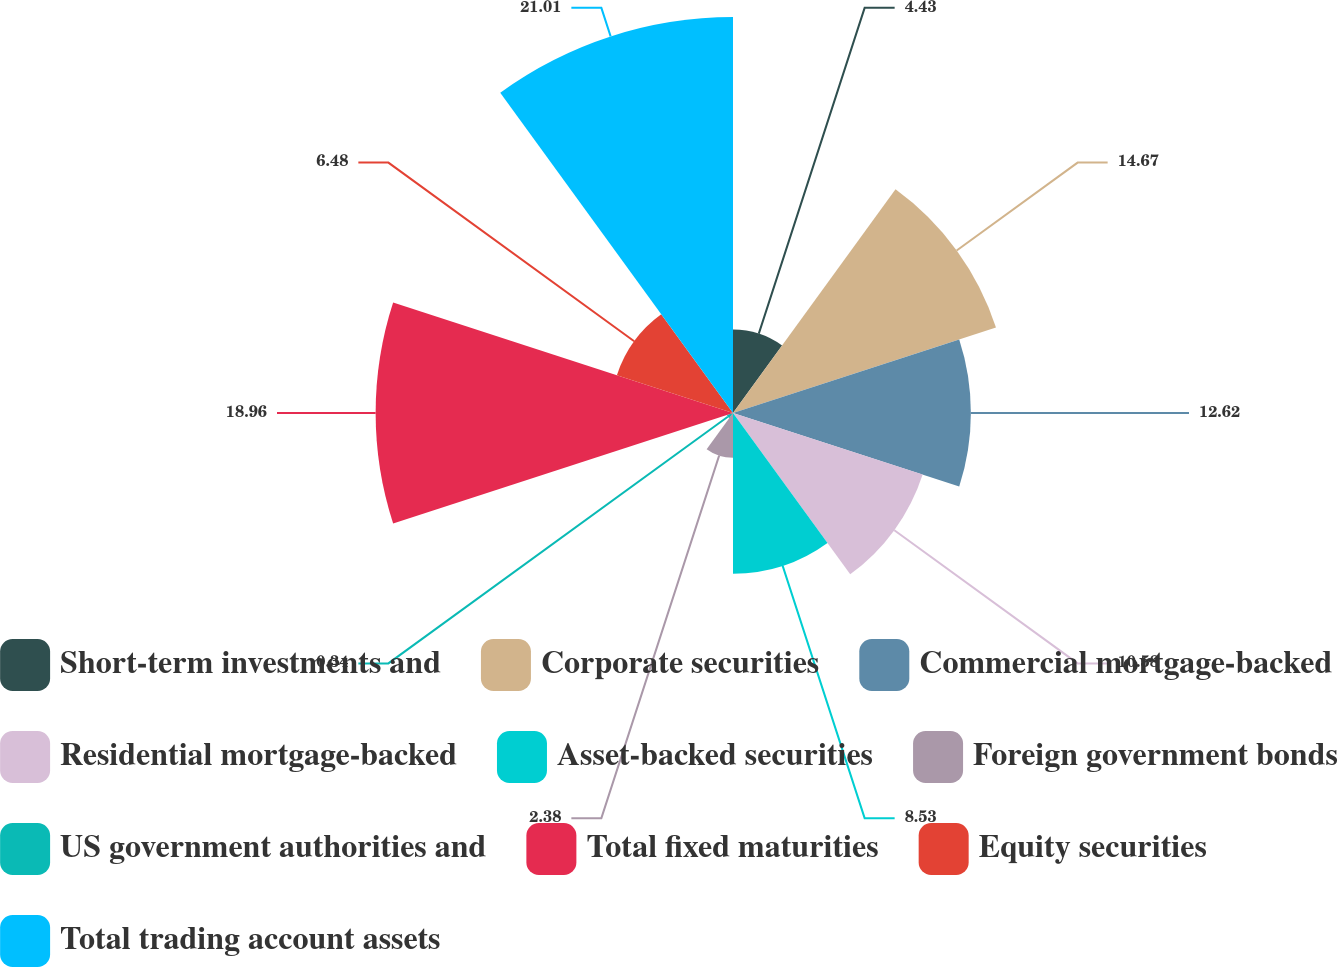Convert chart. <chart><loc_0><loc_0><loc_500><loc_500><pie_chart><fcel>Short-term investments and<fcel>Corporate securities<fcel>Commercial mortgage-backed<fcel>Residential mortgage-backed<fcel>Asset-backed securities<fcel>Foreign government bonds<fcel>US government authorities and<fcel>Total fixed maturities<fcel>Equity securities<fcel>Total trading account assets<nl><fcel>4.43%<fcel>14.67%<fcel>12.62%<fcel>10.58%<fcel>8.53%<fcel>2.38%<fcel>0.34%<fcel>18.96%<fcel>6.48%<fcel>21.01%<nl></chart> 